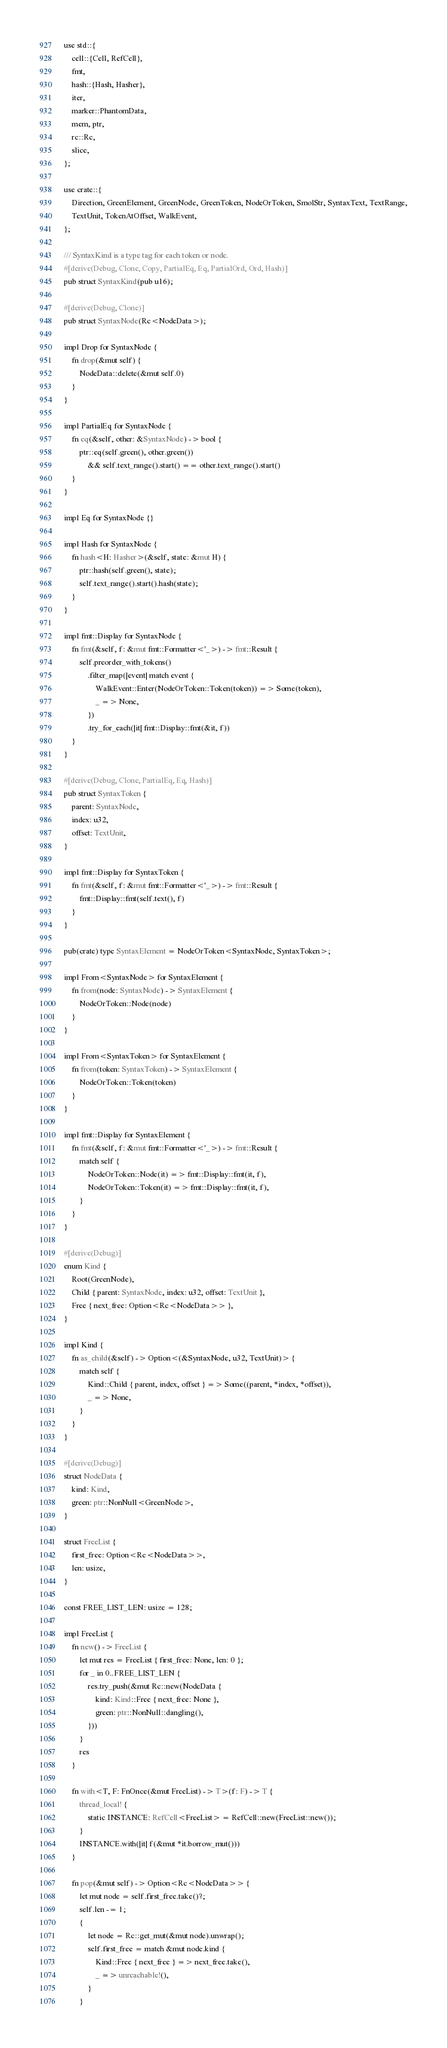<code> <loc_0><loc_0><loc_500><loc_500><_Rust_>use std::{
    cell::{Cell, RefCell},
    fmt,
    hash::{Hash, Hasher},
    iter,
    marker::PhantomData,
    mem, ptr,
    rc::Rc,
    slice,
};

use crate::{
    Direction, GreenElement, GreenNode, GreenToken, NodeOrToken, SmolStr, SyntaxText, TextRange,
    TextUnit, TokenAtOffset, WalkEvent,
};

/// SyntaxKind is a type tag for each token or node.
#[derive(Debug, Clone, Copy, PartialEq, Eq, PartialOrd, Ord, Hash)]
pub struct SyntaxKind(pub u16);

#[derive(Debug, Clone)]
pub struct SyntaxNode(Rc<NodeData>);

impl Drop for SyntaxNode {
    fn drop(&mut self) {
        NodeData::delete(&mut self.0)
    }
}

impl PartialEq for SyntaxNode {
    fn eq(&self, other: &SyntaxNode) -> bool {
        ptr::eq(self.green(), other.green())
            && self.text_range().start() == other.text_range().start()
    }
}

impl Eq for SyntaxNode {}

impl Hash for SyntaxNode {
    fn hash<H: Hasher>(&self, state: &mut H) {
        ptr::hash(self.green(), state);
        self.text_range().start().hash(state);
    }
}

impl fmt::Display for SyntaxNode {
    fn fmt(&self, f: &mut fmt::Formatter<'_>) -> fmt::Result {
        self.preorder_with_tokens()
            .filter_map(|event| match event {
                WalkEvent::Enter(NodeOrToken::Token(token)) => Some(token),
                _ => None,
            })
            .try_for_each(|it| fmt::Display::fmt(&it, f))
    }
}

#[derive(Debug, Clone, PartialEq, Eq, Hash)]
pub struct SyntaxToken {
    parent: SyntaxNode,
    index: u32,
    offset: TextUnit,
}

impl fmt::Display for SyntaxToken {
    fn fmt(&self, f: &mut fmt::Formatter<'_>) -> fmt::Result {
        fmt::Display::fmt(self.text(), f)
    }
}

pub(crate) type SyntaxElement = NodeOrToken<SyntaxNode, SyntaxToken>;

impl From<SyntaxNode> for SyntaxElement {
    fn from(node: SyntaxNode) -> SyntaxElement {
        NodeOrToken::Node(node)
    }
}

impl From<SyntaxToken> for SyntaxElement {
    fn from(token: SyntaxToken) -> SyntaxElement {
        NodeOrToken::Token(token)
    }
}

impl fmt::Display for SyntaxElement {
    fn fmt(&self, f: &mut fmt::Formatter<'_>) -> fmt::Result {
        match self {
            NodeOrToken::Node(it) => fmt::Display::fmt(it, f),
            NodeOrToken::Token(it) => fmt::Display::fmt(it, f),
        }
    }
}

#[derive(Debug)]
enum Kind {
    Root(GreenNode),
    Child { parent: SyntaxNode, index: u32, offset: TextUnit },
    Free { next_free: Option<Rc<NodeData>> },
}

impl Kind {
    fn as_child(&self) -> Option<(&SyntaxNode, u32, TextUnit)> {
        match self {
            Kind::Child { parent, index, offset } => Some((parent, *index, *offset)),
            _ => None,
        }
    }
}

#[derive(Debug)]
struct NodeData {
    kind: Kind,
    green: ptr::NonNull<GreenNode>,
}

struct FreeList {
    first_free: Option<Rc<NodeData>>,
    len: usize,
}

const FREE_LIST_LEN: usize = 128;

impl FreeList {
    fn new() -> FreeList {
        let mut res = FreeList { first_free: None, len: 0 };
        for _ in 0..FREE_LIST_LEN {
            res.try_push(&mut Rc::new(NodeData {
                kind: Kind::Free { next_free: None },
                green: ptr::NonNull::dangling(),
            }))
        }
        res
    }

    fn with<T, F: FnOnce(&mut FreeList) -> T>(f: F) -> T {
        thread_local! {
            static INSTANCE: RefCell<FreeList> = RefCell::new(FreeList::new());
        }
        INSTANCE.with(|it| f(&mut *it.borrow_mut()))
    }

    fn pop(&mut self) -> Option<Rc<NodeData>> {
        let mut node = self.first_free.take()?;
        self.len -= 1;
        {
            let node = Rc::get_mut(&mut node).unwrap();
            self.first_free = match &mut node.kind {
                Kind::Free { next_free } => next_free.take(),
                _ => unreachable!(),
            }
        }</code> 